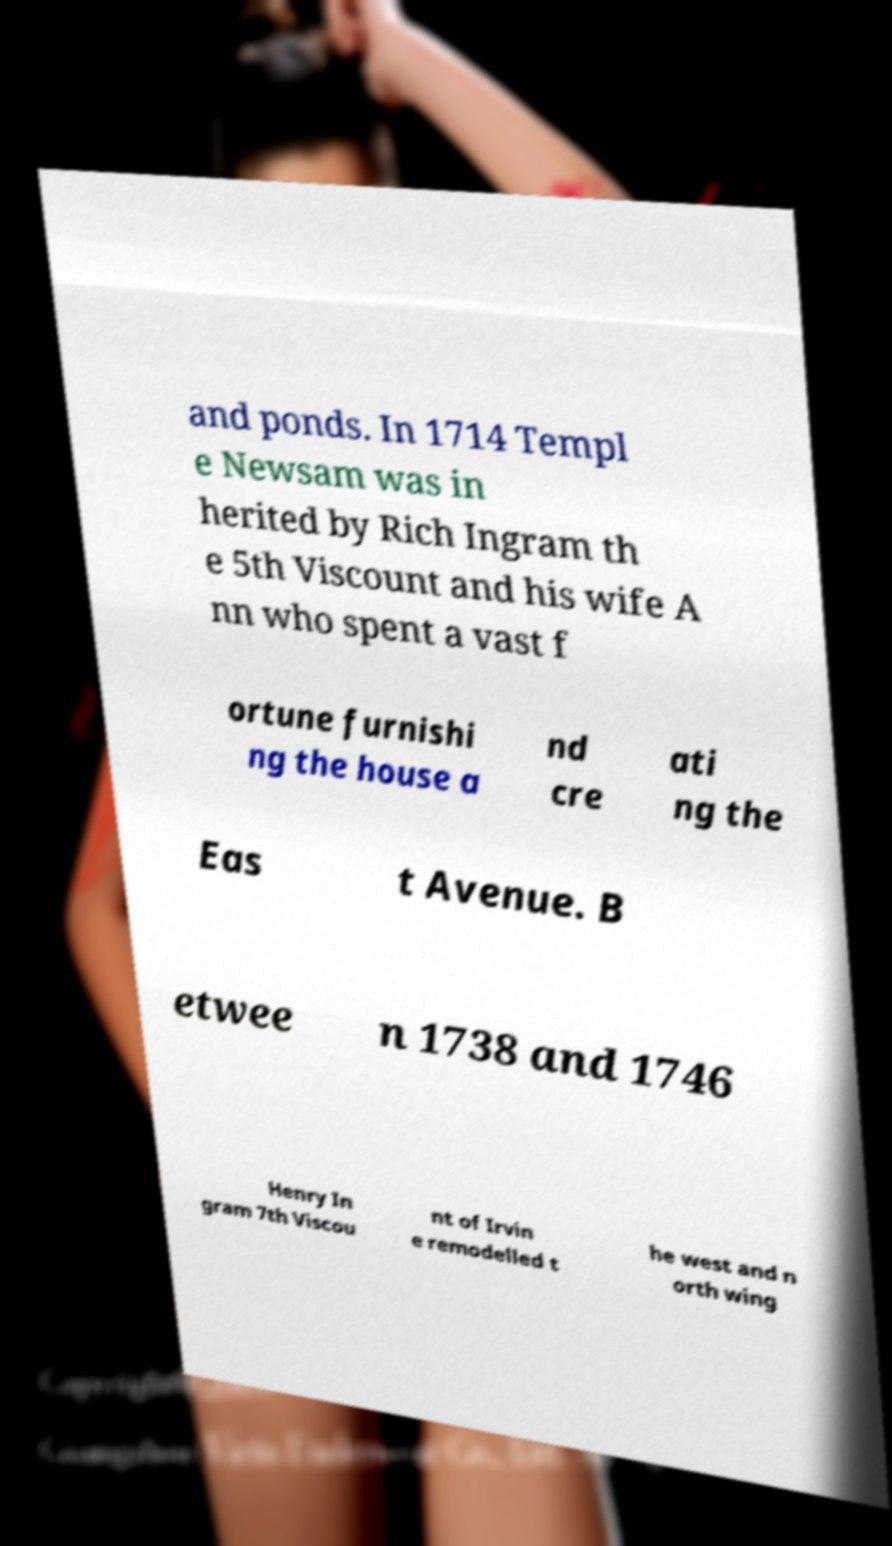Please identify and transcribe the text found in this image. and ponds. In 1714 Templ e Newsam was in herited by Rich Ingram th e 5th Viscount and his wife A nn who spent a vast f ortune furnishi ng the house a nd cre ati ng the Eas t Avenue. B etwee n 1738 and 1746 Henry In gram 7th Viscou nt of Irvin e remodelled t he west and n orth wing 